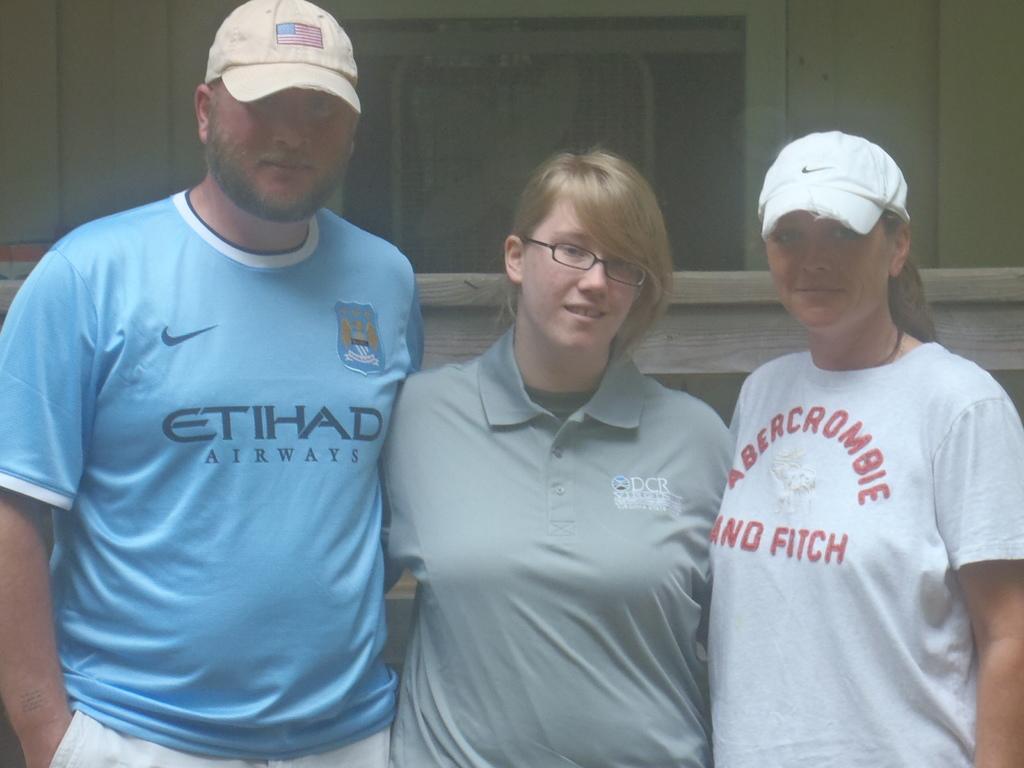What is the brand of shirt on the far right?
Keep it short and to the point. Abercrombie and fitch. 